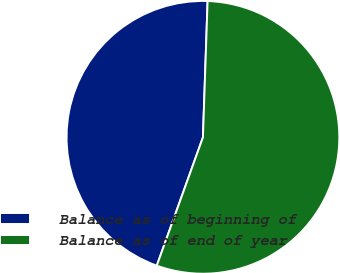<chart> <loc_0><loc_0><loc_500><loc_500><pie_chart><fcel>Balance as of beginning of<fcel>Balance as of end of year<nl><fcel>45.05%<fcel>54.95%<nl></chart> 